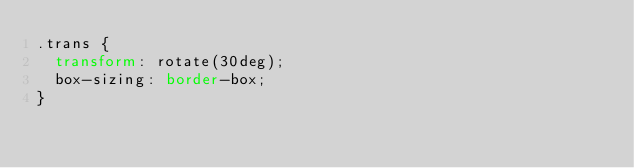Convert code to text. <code><loc_0><loc_0><loc_500><loc_500><_CSS_>.trans {
  transform: rotate(30deg);
  box-sizing: border-box;
}
</code> 